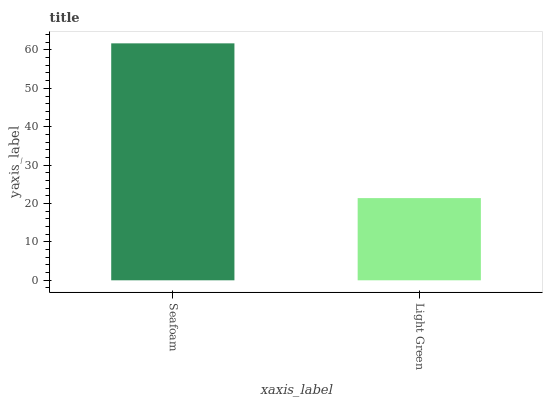Is Light Green the maximum?
Answer yes or no. No. Is Seafoam greater than Light Green?
Answer yes or no. Yes. Is Light Green less than Seafoam?
Answer yes or no. Yes. Is Light Green greater than Seafoam?
Answer yes or no. No. Is Seafoam less than Light Green?
Answer yes or no. No. Is Seafoam the high median?
Answer yes or no. Yes. Is Light Green the low median?
Answer yes or no. Yes. Is Light Green the high median?
Answer yes or no. No. Is Seafoam the low median?
Answer yes or no. No. 